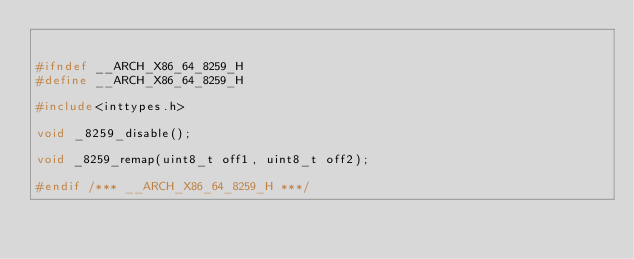<code> <loc_0><loc_0><loc_500><loc_500><_C_>

#ifndef __ARCH_X86_64_8259_H
#define __ARCH_X86_64_8259_H

#include<inttypes.h>

void _8259_disable();

void _8259_remap(uint8_t off1, uint8_t off2);

#endif /*** __ARCH_X86_64_8259_H ***/

</code> 